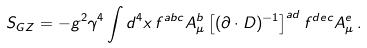Convert formula to latex. <formula><loc_0><loc_0><loc_500><loc_500>S _ { G Z } = - g ^ { 2 } \gamma ^ { 4 } \int { d ^ { 4 } x } \, f ^ { a b c } A ^ { b } _ { \mu } \left [ ( \partial \cdot D ) ^ { - 1 } \right ] ^ { a d } f ^ { d e c } A ^ { e } _ { \mu } \, .</formula> 